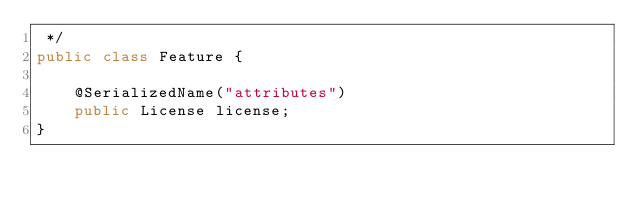Convert code to text. <code><loc_0><loc_0><loc_500><loc_500><_Java_> */
public class Feature {

    @SerializedName("attributes")
    public License license;
}
</code> 